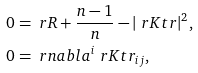Convert formula to latex. <formula><loc_0><loc_0><loc_500><loc_500>0 & = \ r R + \frac { n - 1 } { n } - | \ r K t r | ^ { 2 } , \\ 0 & = \ r n a b l a ^ { i } \ r K t r _ { i j } ,</formula> 